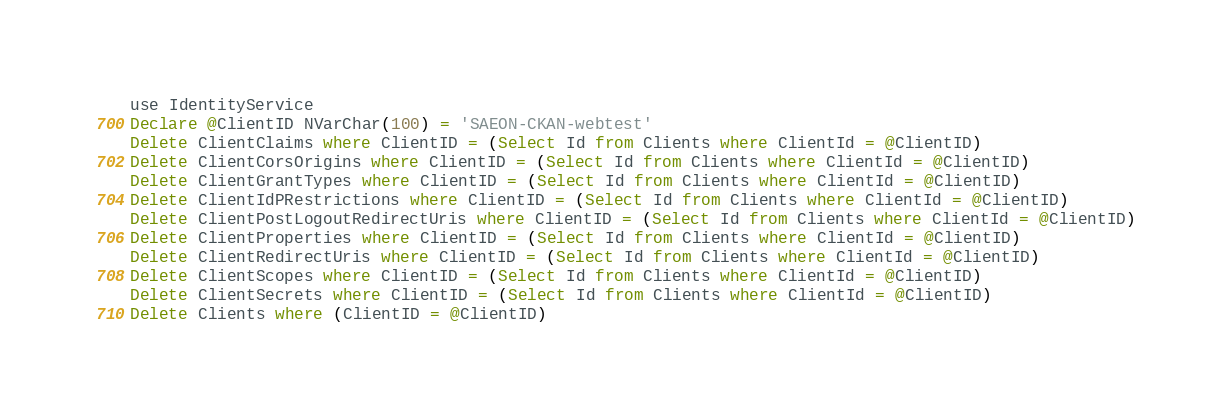Convert code to text. <code><loc_0><loc_0><loc_500><loc_500><_SQL_>use IdentityService
Declare @ClientID NVarChar(100) = 'SAEON-CKAN-webtest'
Delete ClientClaims where ClientID = (Select Id from Clients where ClientId = @ClientID)
Delete ClientCorsOrigins where ClientID = (Select Id from Clients where ClientId = @ClientID)
Delete ClientGrantTypes where ClientID = (Select Id from Clients where ClientId = @ClientID)
Delete ClientIdPRestrictions where ClientID = (Select Id from Clients where ClientId = @ClientID)
Delete ClientPostLogoutRedirectUris where ClientID = (Select Id from Clients where ClientId = @ClientID)
Delete ClientProperties where ClientID = (Select Id from Clients where ClientId = @ClientID)
Delete ClientRedirectUris where ClientID = (Select Id from Clients where ClientId = @ClientID)
Delete ClientScopes where ClientID = (Select Id from Clients where ClientId = @ClientID)
Delete ClientSecrets where ClientID = (Select Id from Clients where ClientId = @ClientID)
Delete Clients where (ClientID = @ClientID)
</code> 